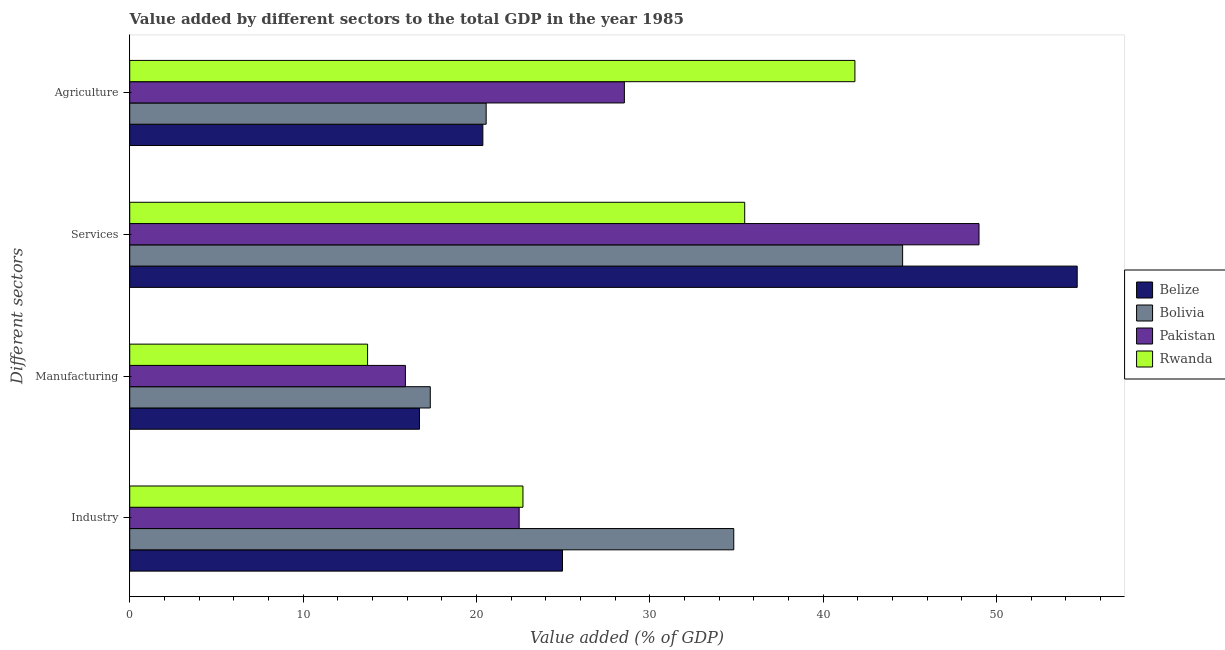How many different coloured bars are there?
Provide a succinct answer. 4. How many groups of bars are there?
Your response must be concise. 4. Are the number of bars per tick equal to the number of legend labels?
Provide a succinct answer. Yes. Are the number of bars on each tick of the Y-axis equal?
Keep it short and to the point. Yes. How many bars are there on the 2nd tick from the top?
Your answer should be compact. 4. How many bars are there on the 4th tick from the bottom?
Ensure brevity in your answer.  4. What is the label of the 3rd group of bars from the top?
Your answer should be very brief. Manufacturing. What is the value added by manufacturing sector in Belize?
Your answer should be very brief. 16.72. Across all countries, what is the maximum value added by manufacturing sector?
Give a very brief answer. 17.34. Across all countries, what is the minimum value added by services sector?
Offer a terse response. 35.48. In which country was the value added by services sector maximum?
Give a very brief answer. Belize. In which country was the value added by agricultural sector minimum?
Keep it short and to the point. Belize. What is the total value added by industrial sector in the graph?
Your response must be concise. 104.97. What is the difference between the value added by manufacturing sector in Pakistan and that in Bolivia?
Provide a succinct answer. -1.44. What is the difference between the value added by services sector in Bolivia and the value added by agricultural sector in Rwanda?
Give a very brief answer. 2.75. What is the average value added by manufacturing sector per country?
Provide a short and direct response. 15.92. What is the difference between the value added by manufacturing sector and value added by agricultural sector in Bolivia?
Provide a short and direct response. -3.22. In how many countries, is the value added by manufacturing sector greater than 10 %?
Offer a terse response. 4. What is the ratio of the value added by industrial sector in Bolivia to that in Pakistan?
Keep it short and to the point. 1.55. Is the value added by services sector in Rwanda less than that in Bolivia?
Provide a short and direct response. Yes. What is the difference between the highest and the second highest value added by industrial sector?
Make the answer very short. 9.88. What is the difference between the highest and the lowest value added by manufacturing sector?
Keep it short and to the point. 3.62. In how many countries, is the value added by manufacturing sector greater than the average value added by manufacturing sector taken over all countries?
Your answer should be very brief. 2. Is the sum of the value added by services sector in Rwanda and Belize greater than the maximum value added by manufacturing sector across all countries?
Keep it short and to the point. Yes. Is it the case that in every country, the sum of the value added by agricultural sector and value added by services sector is greater than the sum of value added by manufacturing sector and value added by industrial sector?
Provide a succinct answer. No. What does the 1st bar from the top in Agriculture represents?
Ensure brevity in your answer.  Rwanda. How many bars are there?
Provide a short and direct response. 16. Are all the bars in the graph horizontal?
Ensure brevity in your answer.  Yes. Are the values on the major ticks of X-axis written in scientific E-notation?
Give a very brief answer. No. Does the graph contain grids?
Provide a succinct answer. No. Where does the legend appear in the graph?
Offer a very short reply. Center right. How many legend labels are there?
Provide a short and direct response. 4. How are the legend labels stacked?
Make the answer very short. Vertical. What is the title of the graph?
Your response must be concise. Value added by different sectors to the total GDP in the year 1985. What is the label or title of the X-axis?
Your response must be concise. Value added (% of GDP). What is the label or title of the Y-axis?
Offer a very short reply. Different sectors. What is the Value added (% of GDP) of Belize in Industry?
Ensure brevity in your answer.  24.97. What is the Value added (% of GDP) in Bolivia in Industry?
Ensure brevity in your answer.  34.85. What is the Value added (% of GDP) of Pakistan in Industry?
Provide a short and direct response. 22.47. What is the Value added (% of GDP) of Rwanda in Industry?
Make the answer very short. 22.69. What is the Value added (% of GDP) of Belize in Manufacturing?
Your response must be concise. 16.72. What is the Value added (% of GDP) of Bolivia in Manufacturing?
Keep it short and to the point. 17.34. What is the Value added (% of GDP) in Pakistan in Manufacturing?
Provide a short and direct response. 15.9. What is the Value added (% of GDP) in Rwanda in Manufacturing?
Your answer should be very brief. 13.72. What is the Value added (% of GDP) in Belize in Services?
Provide a short and direct response. 54.66. What is the Value added (% of GDP) in Bolivia in Services?
Ensure brevity in your answer.  44.59. What is the Value added (% of GDP) of Pakistan in Services?
Provide a short and direct response. 49. What is the Value added (% of GDP) of Rwanda in Services?
Ensure brevity in your answer.  35.48. What is the Value added (% of GDP) of Belize in Agriculture?
Give a very brief answer. 20.37. What is the Value added (% of GDP) in Bolivia in Agriculture?
Make the answer very short. 20.56. What is the Value added (% of GDP) in Pakistan in Agriculture?
Give a very brief answer. 28.54. What is the Value added (% of GDP) of Rwanda in Agriculture?
Offer a terse response. 41.84. Across all Different sectors, what is the maximum Value added (% of GDP) of Belize?
Ensure brevity in your answer.  54.66. Across all Different sectors, what is the maximum Value added (% of GDP) of Bolivia?
Offer a terse response. 44.59. Across all Different sectors, what is the maximum Value added (% of GDP) in Pakistan?
Your response must be concise. 49. Across all Different sectors, what is the maximum Value added (% of GDP) of Rwanda?
Your answer should be compact. 41.84. Across all Different sectors, what is the minimum Value added (% of GDP) of Belize?
Offer a very short reply. 16.72. Across all Different sectors, what is the minimum Value added (% of GDP) in Bolivia?
Offer a terse response. 17.34. Across all Different sectors, what is the minimum Value added (% of GDP) of Pakistan?
Keep it short and to the point. 15.9. Across all Different sectors, what is the minimum Value added (% of GDP) of Rwanda?
Keep it short and to the point. 13.72. What is the total Value added (% of GDP) of Belize in the graph?
Your answer should be very brief. 116.72. What is the total Value added (% of GDP) in Bolivia in the graph?
Your answer should be very brief. 117.34. What is the total Value added (% of GDP) of Pakistan in the graph?
Make the answer very short. 115.9. What is the total Value added (% of GDP) in Rwanda in the graph?
Offer a terse response. 113.72. What is the difference between the Value added (% of GDP) in Belize in Industry and that in Manufacturing?
Ensure brevity in your answer.  8.25. What is the difference between the Value added (% of GDP) of Bolivia in Industry and that in Manufacturing?
Your answer should be very brief. 17.51. What is the difference between the Value added (% of GDP) of Pakistan in Industry and that in Manufacturing?
Provide a succinct answer. 6.56. What is the difference between the Value added (% of GDP) of Rwanda in Industry and that in Manufacturing?
Provide a succinct answer. 8.96. What is the difference between the Value added (% of GDP) of Belize in Industry and that in Services?
Offer a terse response. -29.69. What is the difference between the Value added (% of GDP) of Bolivia in Industry and that in Services?
Offer a very short reply. -9.74. What is the difference between the Value added (% of GDP) in Pakistan in Industry and that in Services?
Keep it short and to the point. -26.53. What is the difference between the Value added (% of GDP) in Rwanda in Industry and that in Services?
Your answer should be compact. -12.79. What is the difference between the Value added (% of GDP) of Belize in Industry and that in Agriculture?
Give a very brief answer. 4.59. What is the difference between the Value added (% of GDP) in Bolivia in Industry and that in Agriculture?
Keep it short and to the point. 14.28. What is the difference between the Value added (% of GDP) in Pakistan in Industry and that in Agriculture?
Give a very brief answer. -6.07. What is the difference between the Value added (% of GDP) in Rwanda in Industry and that in Agriculture?
Your answer should be very brief. -19.15. What is the difference between the Value added (% of GDP) of Belize in Manufacturing and that in Services?
Ensure brevity in your answer.  -37.94. What is the difference between the Value added (% of GDP) of Bolivia in Manufacturing and that in Services?
Provide a succinct answer. -27.25. What is the difference between the Value added (% of GDP) in Pakistan in Manufacturing and that in Services?
Offer a very short reply. -33.09. What is the difference between the Value added (% of GDP) of Rwanda in Manufacturing and that in Services?
Keep it short and to the point. -21.76. What is the difference between the Value added (% of GDP) in Belize in Manufacturing and that in Agriculture?
Give a very brief answer. -3.65. What is the difference between the Value added (% of GDP) in Bolivia in Manufacturing and that in Agriculture?
Your response must be concise. -3.22. What is the difference between the Value added (% of GDP) in Pakistan in Manufacturing and that in Agriculture?
Your answer should be very brief. -12.63. What is the difference between the Value added (% of GDP) in Rwanda in Manufacturing and that in Agriculture?
Provide a short and direct response. -28.11. What is the difference between the Value added (% of GDP) in Belize in Services and that in Agriculture?
Offer a terse response. 34.29. What is the difference between the Value added (% of GDP) in Bolivia in Services and that in Agriculture?
Offer a terse response. 24.03. What is the difference between the Value added (% of GDP) in Pakistan in Services and that in Agriculture?
Ensure brevity in your answer.  20.46. What is the difference between the Value added (% of GDP) of Rwanda in Services and that in Agriculture?
Make the answer very short. -6.36. What is the difference between the Value added (% of GDP) in Belize in Industry and the Value added (% of GDP) in Bolivia in Manufacturing?
Give a very brief answer. 7.63. What is the difference between the Value added (% of GDP) in Belize in Industry and the Value added (% of GDP) in Pakistan in Manufacturing?
Ensure brevity in your answer.  9.06. What is the difference between the Value added (% of GDP) in Belize in Industry and the Value added (% of GDP) in Rwanda in Manufacturing?
Your response must be concise. 11.25. What is the difference between the Value added (% of GDP) of Bolivia in Industry and the Value added (% of GDP) of Pakistan in Manufacturing?
Offer a terse response. 18.94. What is the difference between the Value added (% of GDP) in Bolivia in Industry and the Value added (% of GDP) in Rwanda in Manufacturing?
Keep it short and to the point. 21.13. What is the difference between the Value added (% of GDP) of Pakistan in Industry and the Value added (% of GDP) of Rwanda in Manufacturing?
Keep it short and to the point. 8.75. What is the difference between the Value added (% of GDP) in Belize in Industry and the Value added (% of GDP) in Bolivia in Services?
Your answer should be very brief. -19.62. What is the difference between the Value added (% of GDP) in Belize in Industry and the Value added (% of GDP) in Pakistan in Services?
Make the answer very short. -24.03. What is the difference between the Value added (% of GDP) in Belize in Industry and the Value added (% of GDP) in Rwanda in Services?
Your answer should be compact. -10.51. What is the difference between the Value added (% of GDP) in Bolivia in Industry and the Value added (% of GDP) in Pakistan in Services?
Ensure brevity in your answer.  -14.15. What is the difference between the Value added (% of GDP) in Bolivia in Industry and the Value added (% of GDP) in Rwanda in Services?
Make the answer very short. -0.63. What is the difference between the Value added (% of GDP) in Pakistan in Industry and the Value added (% of GDP) in Rwanda in Services?
Provide a short and direct response. -13.01. What is the difference between the Value added (% of GDP) of Belize in Industry and the Value added (% of GDP) of Bolivia in Agriculture?
Give a very brief answer. 4.4. What is the difference between the Value added (% of GDP) of Belize in Industry and the Value added (% of GDP) of Pakistan in Agriculture?
Your answer should be very brief. -3.57. What is the difference between the Value added (% of GDP) of Belize in Industry and the Value added (% of GDP) of Rwanda in Agriculture?
Your response must be concise. -16.87. What is the difference between the Value added (% of GDP) of Bolivia in Industry and the Value added (% of GDP) of Pakistan in Agriculture?
Provide a short and direct response. 6.31. What is the difference between the Value added (% of GDP) in Bolivia in Industry and the Value added (% of GDP) in Rwanda in Agriculture?
Give a very brief answer. -6.99. What is the difference between the Value added (% of GDP) of Pakistan in Industry and the Value added (% of GDP) of Rwanda in Agriculture?
Give a very brief answer. -19.37. What is the difference between the Value added (% of GDP) of Belize in Manufacturing and the Value added (% of GDP) of Bolivia in Services?
Your response must be concise. -27.87. What is the difference between the Value added (% of GDP) in Belize in Manufacturing and the Value added (% of GDP) in Pakistan in Services?
Your answer should be compact. -32.28. What is the difference between the Value added (% of GDP) of Belize in Manufacturing and the Value added (% of GDP) of Rwanda in Services?
Ensure brevity in your answer.  -18.76. What is the difference between the Value added (% of GDP) in Bolivia in Manufacturing and the Value added (% of GDP) in Pakistan in Services?
Offer a terse response. -31.66. What is the difference between the Value added (% of GDP) in Bolivia in Manufacturing and the Value added (% of GDP) in Rwanda in Services?
Provide a short and direct response. -18.14. What is the difference between the Value added (% of GDP) in Pakistan in Manufacturing and the Value added (% of GDP) in Rwanda in Services?
Your answer should be very brief. -19.57. What is the difference between the Value added (% of GDP) of Belize in Manufacturing and the Value added (% of GDP) of Bolivia in Agriculture?
Make the answer very short. -3.85. What is the difference between the Value added (% of GDP) in Belize in Manufacturing and the Value added (% of GDP) in Pakistan in Agriculture?
Offer a very short reply. -11.82. What is the difference between the Value added (% of GDP) of Belize in Manufacturing and the Value added (% of GDP) of Rwanda in Agriculture?
Provide a succinct answer. -25.12. What is the difference between the Value added (% of GDP) of Bolivia in Manufacturing and the Value added (% of GDP) of Pakistan in Agriculture?
Make the answer very short. -11.2. What is the difference between the Value added (% of GDP) of Bolivia in Manufacturing and the Value added (% of GDP) of Rwanda in Agriculture?
Your answer should be compact. -24.5. What is the difference between the Value added (% of GDP) of Pakistan in Manufacturing and the Value added (% of GDP) of Rwanda in Agriculture?
Give a very brief answer. -25.93. What is the difference between the Value added (% of GDP) of Belize in Services and the Value added (% of GDP) of Bolivia in Agriculture?
Give a very brief answer. 34.1. What is the difference between the Value added (% of GDP) of Belize in Services and the Value added (% of GDP) of Pakistan in Agriculture?
Ensure brevity in your answer.  26.12. What is the difference between the Value added (% of GDP) of Belize in Services and the Value added (% of GDP) of Rwanda in Agriculture?
Offer a terse response. 12.82. What is the difference between the Value added (% of GDP) in Bolivia in Services and the Value added (% of GDP) in Pakistan in Agriculture?
Offer a terse response. 16.05. What is the difference between the Value added (% of GDP) of Bolivia in Services and the Value added (% of GDP) of Rwanda in Agriculture?
Keep it short and to the point. 2.75. What is the difference between the Value added (% of GDP) in Pakistan in Services and the Value added (% of GDP) in Rwanda in Agriculture?
Keep it short and to the point. 7.16. What is the average Value added (% of GDP) of Belize per Different sectors?
Offer a terse response. 29.18. What is the average Value added (% of GDP) in Bolivia per Different sectors?
Make the answer very short. 29.33. What is the average Value added (% of GDP) of Pakistan per Different sectors?
Provide a succinct answer. 28.98. What is the average Value added (% of GDP) of Rwanda per Different sectors?
Your response must be concise. 28.43. What is the difference between the Value added (% of GDP) in Belize and Value added (% of GDP) in Bolivia in Industry?
Your answer should be very brief. -9.88. What is the difference between the Value added (% of GDP) of Belize and Value added (% of GDP) of Rwanda in Industry?
Your response must be concise. 2.28. What is the difference between the Value added (% of GDP) in Bolivia and Value added (% of GDP) in Pakistan in Industry?
Your answer should be very brief. 12.38. What is the difference between the Value added (% of GDP) in Bolivia and Value added (% of GDP) in Rwanda in Industry?
Your response must be concise. 12.16. What is the difference between the Value added (% of GDP) of Pakistan and Value added (% of GDP) of Rwanda in Industry?
Your response must be concise. -0.22. What is the difference between the Value added (% of GDP) in Belize and Value added (% of GDP) in Bolivia in Manufacturing?
Provide a short and direct response. -0.62. What is the difference between the Value added (% of GDP) in Belize and Value added (% of GDP) in Pakistan in Manufacturing?
Provide a succinct answer. 0.81. What is the difference between the Value added (% of GDP) in Belize and Value added (% of GDP) in Rwanda in Manufacturing?
Keep it short and to the point. 3. What is the difference between the Value added (% of GDP) in Bolivia and Value added (% of GDP) in Pakistan in Manufacturing?
Give a very brief answer. 1.44. What is the difference between the Value added (% of GDP) in Bolivia and Value added (% of GDP) in Rwanda in Manufacturing?
Your answer should be very brief. 3.62. What is the difference between the Value added (% of GDP) in Pakistan and Value added (% of GDP) in Rwanda in Manufacturing?
Give a very brief answer. 2.18. What is the difference between the Value added (% of GDP) of Belize and Value added (% of GDP) of Bolivia in Services?
Keep it short and to the point. 10.07. What is the difference between the Value added (% of GDP) of Belize and Value added (% of GDP) of Pakistan in Services?
Make the answer very short. 5.66. What is the difference between the Value added (% of GDP) of Belize and Value added (% of GDP) of Rwanda in Services?
Provide a short and direct response. 19.18. What is the difference between the Value added (% of GDP) in Bolivia and Value added (% of GDP) in Pakistan in Services?
Your answer should be very brief. -4.41. What is the difference between the Value added (% of GDP) of Bolivia and Value added (% of GDP) of Rwanda in Services?
Offer a terse response. 9.11. What is the difference between the Value added (% of GDP) of Pakistan and Value added (% of GDP) of Rwanda in Services?
Offer a terse response. 13.52. What is the difference between the Value added (% of GDP) in Belize and Value added (% of GDP) in Bolivia in Agriculture?
Make the answer very short. -0.19. What is the difference between the Value added (% of GDP) of Belize and Value added (% of GDP) of Pakistan in Agriculture?
Make the answer very short. -8.16. What is the difference between the Value added (% of GDP) in Belize and Value added (% of GDP) in Rwanda in Agriculture?
Provide a succinct answer. -21.46. What is the difference between the Value added (% of GDP) of Bolivia and Value added (% of GDP) of Pakistan in Agriculture?
Your answer should be very brief. -7.97. What is the difference between the Value added (% of GDP) of Bolivia and Value added (% of GDP) of Rwanda in Agriculture?
Your answer should be compact. -21.27. What is the difference between the Value added (% of GDP) in Pakistan and Value added (% of GDP) in Rwanda in Agriculture?
Make the answer very short. -13.3. What is the ratio of the Value added (% of GDP) of Belize in Industry to that in Manufacturing?
Provide a short and direct response. 1.49. What is the ratio of the Value added (% of GDP) of Bolivia in Industry to that in Manufacturing?
Your answer should be compact. 2.01. What is the ratio of the Value added (% of GDP) of Pakistan in Industry to that in Manufacturing?
Keep it short and to the point. 1.41. What is the ratio of the Value added (% of GDP) of Rwanda in Industry to that in Manufacturing?
Make the answer very short. 1.65. What is the ratio of the Value added (% of GDP) of Belize in Industry to that in Services?
Provide a succinct answer. 0.46. What is the ratio of the Value added (% of GDP) in Bolivia in Industry to that in Services?
Your response must be concise. 0.78. What is the ratio of the Value added (% of GDP) in Pakistan in Industry to that in Services?
Give a very brief answer. 0.46. What is the ratio of the Value added (% of GDP) in Rwanda in Industry to that in Services?
Offer a terse response. 0.64. What is the ratio of the Value added (% of GDP) of Belize in Industry to that in Agriculture?
Ensure brevity in your answer.  1.23. What is the ratio of the Value added (% of GDP) in Bolivia in Industry to that in Agriculture?
Keep it short and to the point. 1.69. What is the ratio of the Value added (% of GDP) of Pakistan in Industry to that in Agriculture?
Keep it short and to the point. 0.79. What is the ratio of the Value added (% of GDP) in Rwanda in Industry to that in Agriculture?
Keep it short and to the point. 0.54. What is the ratio of the Value added (% of GDP) in Belize in Manufacturing to that in Services?
Your response must be concise. 0.31. What is the ratio of the Value added (% of GDP) of Bolivia in Manufacturing to that in Services?
Offer a very short reply. 0.39. What is the ratio of the Value added (% of GDP) in Pakistan in Manufacturing to that in Services?
Provide a short and direct response. 0.32. What is the ratio of the Value added (% of GDP) of Rwanda in Manufacturing to that in Services?
Offer a terse response. 0.39. What is the ratio of the Value added (% of GDP) in Belize in Manufacturing to that in Agriculture?
Your response must be concise. 0.82. What is the ratio of the Value added (% of GDP) in Bolivia in Manufacturing to that in Agriculture?
Ensure brevity in your answer.  0.84. What is the ratio of the Value added (% of GDP) in Pakistan in Manufacturing to that in Agriculture?
Offer a terse response. 0.56. What is the ratio of the Value added (% of GDP) in Rwanda in Manufacturing to that in Agriculture?
Your response must be concise. 0.33. What is the ratio of the Value added (% of GDP) of Belize in Services to that in Agriculture?
Ensure brevity in your answer.  2.68. What is the ratio of the Value added (% of GDP) of Bolivia in Services to that in Agriculture?
Give a very brief answer. 2.17. What is the ratio of the Value added (% of GDP) in Pakistan in Services to that in Agriculture?
Give a very brief answer. 1.72. What is the ratio of the Value added (% of GDP) in Rwanda in Services to that in Agriculture?
Keep it short and to the point. 0.85. What is the difference between the highest and the second highest Value added (% of GDP) in Belize?
Offer a very short reply. 29.69. What is the difference between the highest and the second highest Value added (% of GDP) in Bolivia?
Keep it short and to the point. 9.74. What is the difference between the highest and the second highest Value added (% of GDP) of Pakistan?
Keep it short and to the point. 20.46. What is the difference between the highest and the second highest Value added (% of GDP) in Rwanda?
Provide a short and direct response. 6.36. What is the difference between the highest and the lowest Value added (% of GDP) in Belize?
Make the answer very short. 37.94. What is the difference between the highest and the lowest Value added (% of GDP) in Bolivia?
Your response must be concise. 27.25. What is the difference between the highest and the lowest Value added (% of GDP) of Pakistan?
Provide a succinct answer. 33.09. What is the difference between the highest and the lowest Value added (% of GDP) in Rwanda?
Your answer should be compact. 28.11. 